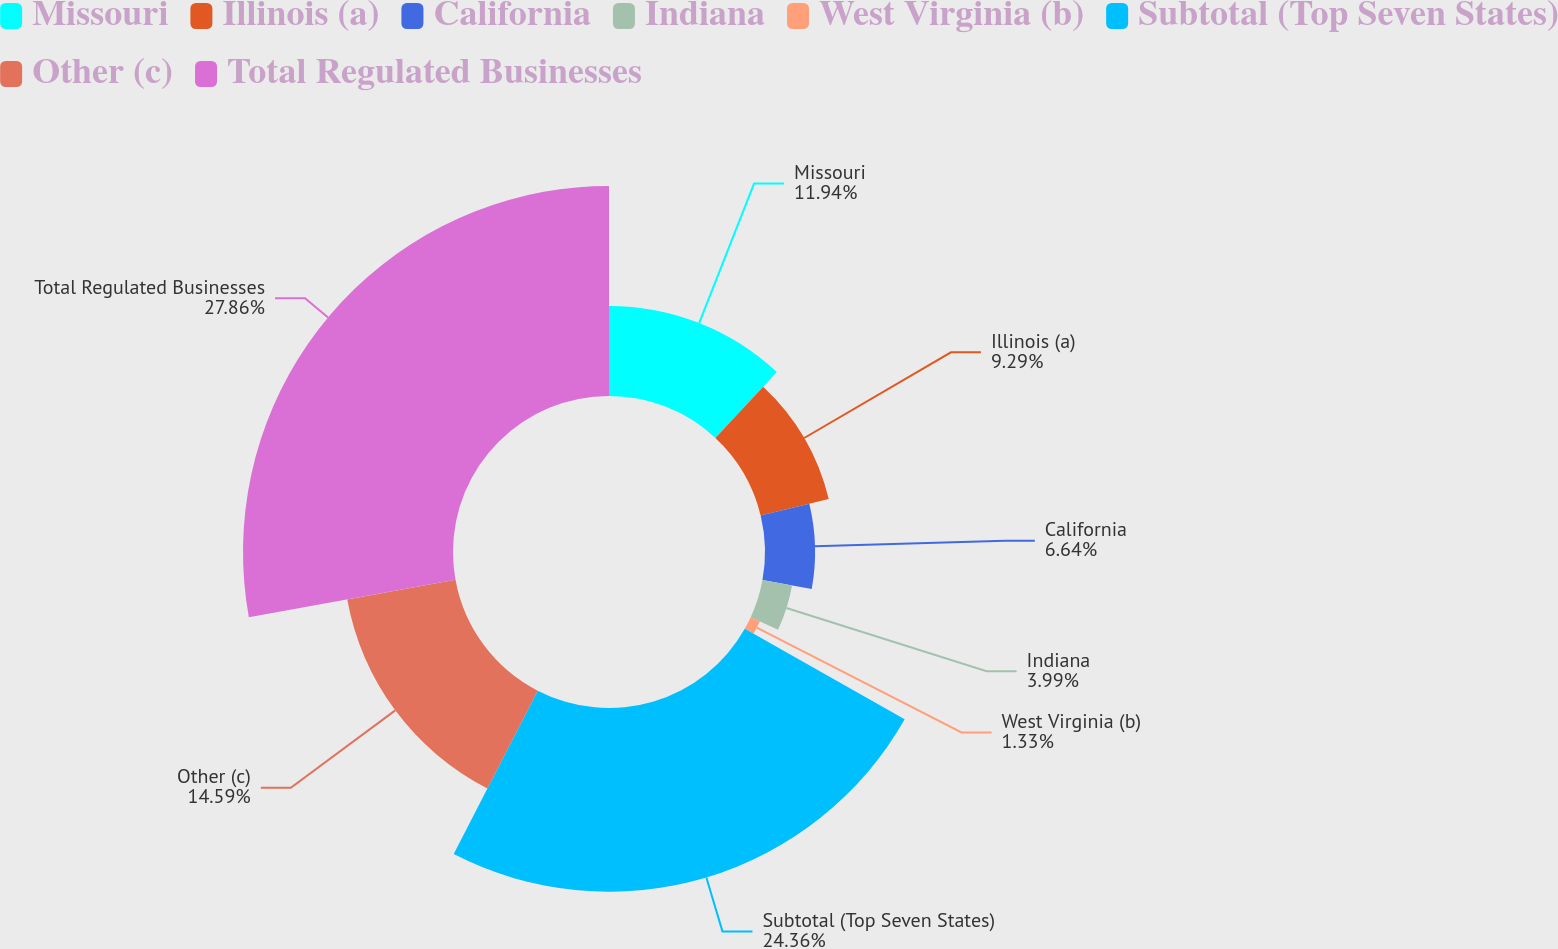Convert chart to OTSL. <chart><loc_0><loc_0><loc_500><loc_500><pie_chart><fcel>Missouri<fcel>Illinois (a)<fcel>California<fcel>Indiana<fcel>West Virginia (b)<fcel>Subtotal (Top Seven States)<fcel>Other (c)<fcel>Total Regulated Businesses<nl><fcel>11.94%<fcel>9.29%<fcel>6.64%<fcel>3.99%<fcel>1.33%<fcel>24.36%<fcel>14.59%<fcel>27.85%<nl></chart> 